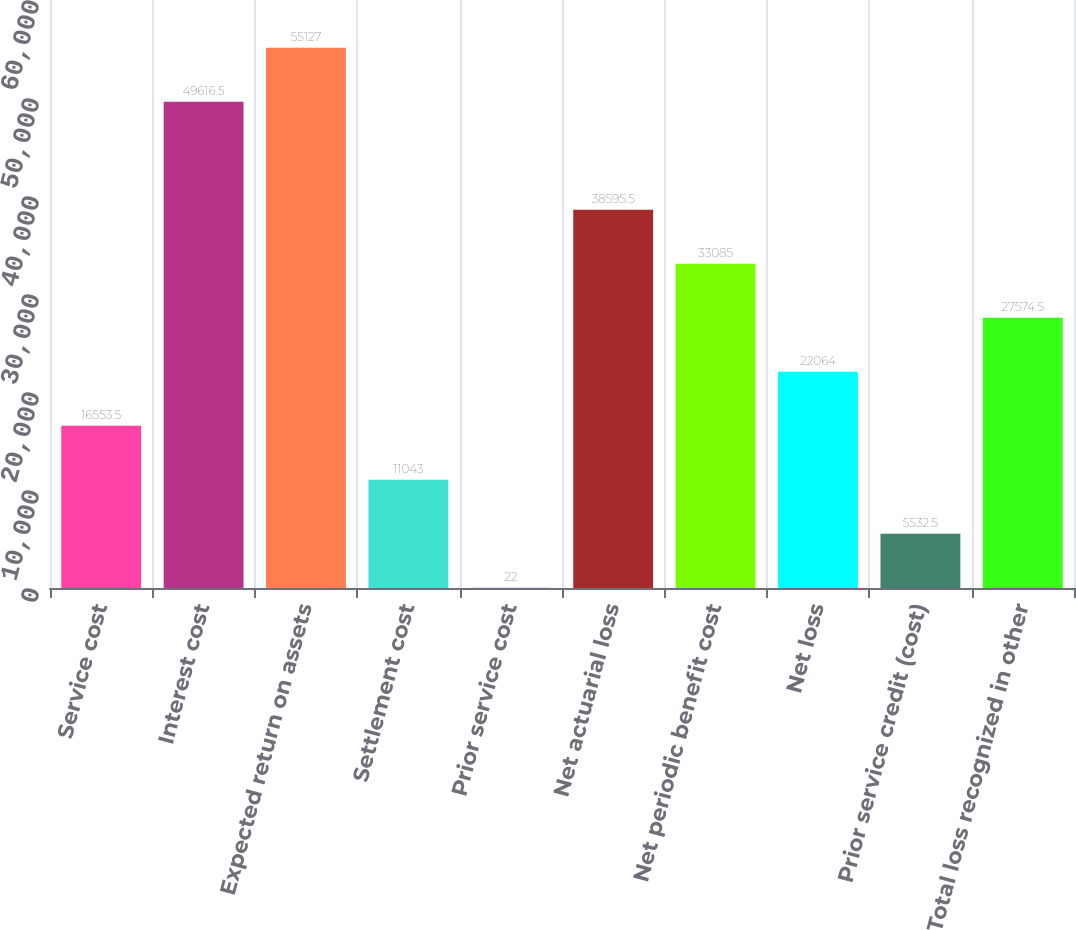Convert chart. <chart><loc_0><loc_0><loc_500><loc_500><bar_chart><fcel>Service cost<fcel>Interest cost<fcel>Expected return on assets<fcel>Settlement cost<fcel>Prior service cost<fcel>Net actuarial loss<fcel>Net periodic benefit cost<fcel>Net loss<fcel>Prior service credit (cost)<fcel>Total loss recognized in other<nl><fcel>16553.5<fcel>49616.5<fcel>55127<fcel>11043<fcel>22<fcel>38595.5<fcel>33085<fcel>22064<fcel>5532.5<fcel>27574.5<nl></chart> 